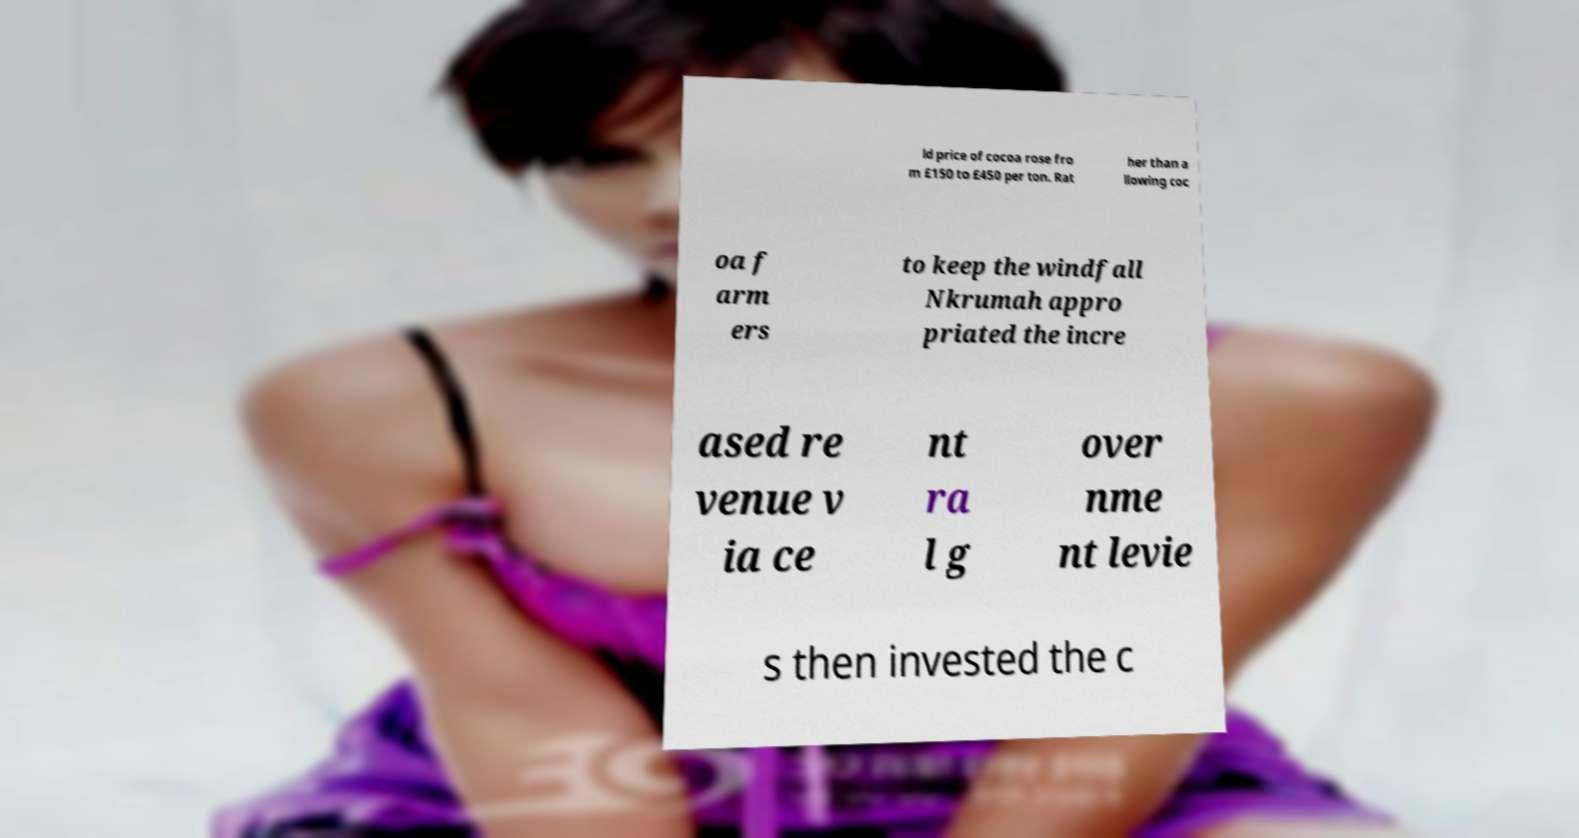Could you extract and type out the text from this image? ld price of cocoa rose fro m £150 to £450 per ton. Rat her than a llowing coc oa f arm ers to keep the windfall Nkrumah appro priated the incre ased re venue v ia ce nt ra l g over nme nt levie s then invested the c 